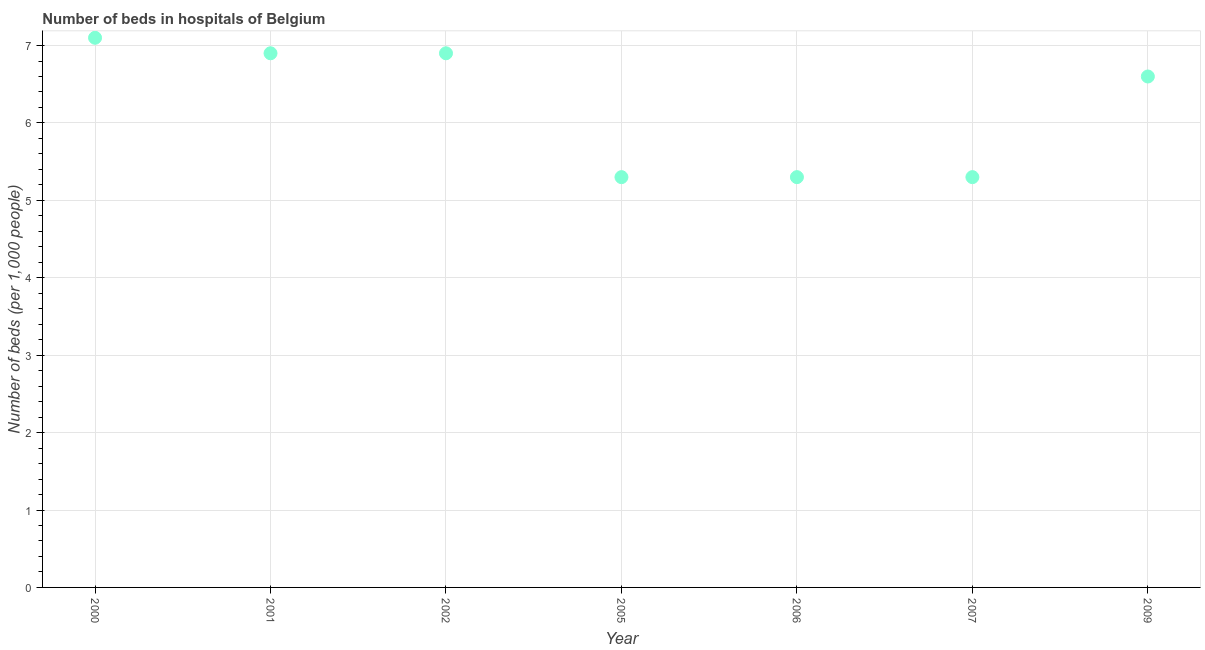Across all years, what is the maximum number of hospital beds?
Offer a very short reply. 7.1. In which year was the number of hospital beds maximum?
Keep it short and to the point. 2000. What is the sum of the number of hospital beds?
Offer a terse response. 43.4. What is the difference between the number of hospital beds in 2000 and 2006?
Your answer should be very brief. 1.8. What is the average number of hospital beds per year?
Your answer should be very brief. 6.2. In how many years, is the number of hospital beds greater than 4 %?
Make the answer very short. 7. What is the ratio of the number of hospital beds in 2005 to that in 2007?
Ensure brevity in your answer.  1. What is the difference between the highest and the second highest number of hospital beds?
Your answer should be very brief. 0.2. Is the sum of the number of hospital beds in 2000 and 2002 greater than the maximum number of hospital beds across all years?
Your answer should be compact. Yes. What is the difference between the highest and the lowest number of hospital beds?
Ensure brevity in your answer.  1.8. In how many years, is the number of hospital beds greater than the average number of hospital beds taken over all years?
Offer a very short reply. 4. Does the number of hospital beds monotonically increase over the years?
Offer a terse response. No. How many dotlines are there?
Provide a short and direct response. 1. What is the difference between two consecutive major ticks on the Y-axis?
Offer a terse response. 1. Are the values on the major ticks of Y-axis written in scientific E-notation?
Provide a short and direct response. No. What is the title of the graph?
Your response must be concise. Number of beds in hospitals of Belgium. What is the label or title of the X-axis?
Your answer should be very brief. Year. What is the label or title of the Y-axis?
Your answer should be very brief. Number of beds (per 1,0 people). What is the Number of beds (per 1,000 people) in 2000?
Ensure brevity in your answer.  7.1. What is the Number of beds (per 1,000 people) in 2001?
Provide a short and direct response. 6.9. What is the Number of beds (per 1,000 people) in 2002?
Offer a terse response. 6.9. What is the Number of beds (per 1,000 people) in 2006?
Your answer should be very brief. 5.3. What is the Number of beds (per 1,000 people) in 2009?
Your answer should be compact. 6.6. What is the difference between the Number of beds (per 1,000 people) in 2000 and 2001?
Offer a terse response. 0.2. What is the difference between the Number of beds (per 1,000 people) in 2000 and 2005?
Ensure brevity in your answer.  1.8. What is the difference between the Number of beds (per 1,000 people) in 2000 and 2006?
Your answer should be compact. 1.8. What is the difference between the Number of beds (per 1,000 people) in 2000 and 2009?
Make the answer very short. 0.5. What is the difference between the Number of beds (per 1,000 people) in 2001 and 2009?
Offer a terse response. 0.3. What is the difference between the Number of beds (per 1,000 people) in 2002 and 2005?
Your response must be concise. 1.6. What is the difference between the Number of beds (per 1,000 people) in 2002 and 2007?
Provide a short and direct response. 1.6. What is the difference between the Number of beds (per 1,000 people) in 2005 and 2009?
Your response must be concise. -1.3. What is the difference between the Number of beds (per 1,000 people) in 2006 and 2007?
Make the answer very short. 0. What is the difference between the Number of beds (per 1,000 people) in 2006 and 2009?
Offer a very short reply. -1.3. What is the ratio of the Number of beds (per 1,000 people) in 2000 to that in 2001?
Give a very brief answer. 1.03. What is the ratio of the Number of beds (per 1,000 people) in 2000 to that in 2002?
Give a very brief answer. 1.03. What is the ratio of the Number of beds (per 1,000 people) in 2000 to that in 2005?
Offer a very short reply. 1.34. What is the ratio of the Number of beds (per 1,000 people) in 2000 to that in 2006?
Ensure brevity in your answer.  1.34. What is the ratio of the Number of beds (per 1,000 people) in 2000 to that in 2007?
Provide a succinct answer. 1.34. What is the ratio of the Number of beds (per 1,000 people) in 2000 to that in 2009?
Offer a terse response. 1.08. What is the ratio of the Number of beds (per 1,000 people) in 2001 to that in 2002?
Your answer should be very brief. 1. What is the ratio of the Number of beds (per 1,000 people) in 2001 to that in 2005?
Your answer should be very brief. 1.3. What is the ratio of the Number of beds (per 1,000 people) in 2001 to that in 2006?
Provide a short and direct response. 1.3. What is the ratio of the Number of beds (per 1,000 people) in 2001 to that in 2007?
Ensure brevity in your answer.  1.3. What is the ratio of the Number of beds (per 1,000 people) in 2001 to that in 2009?
Your response must be concise. 1.04. What is the ratio of the Number of beds (per 1,000 people) in 2002 to that in 2005?
Make the answer very short. 1.3. What is the ratio of the Number of beds (per 1,000 people) in 2002 to that in 2006?
Offer a very short reply. 1.3. What is the ratio of the Number of beds (per 1,000 people) in 2002 to that in 2007?
Make the answer very short. 1.3. What is the ratio of the Number of beds (per 1,000 people) in 2002 to that in 2009?
Offer a very short reply. 1.04. What is the ratio of the Number of beds (per 1,000 people) in 2005 to that in 2006?
Offer a terse response. 1. What is the ratio of the Number of beds (per 1,000 people) in 2005 to that in 2007?
Your answer should be very brief. 1. What is the ratio of the Number of beds (per 1,000 people) in 2005 to that in 2009?
Your answer should be very brief. 0.8. What is the ratio of the Number of beds (per 1,000 people) in 2006 to that in 2009?
Your response must be concise. 0.8. What is the ratio of the Number of beds (per 1,000 people) in 2007 to that in 2009?
Provide a short and direct response. 0.8. 